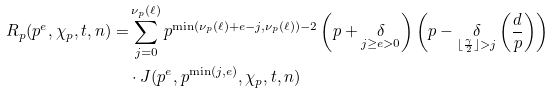Convert formula to latex. <formula><loc_0><loc_0><loc_500><loc_500>R _ { p } ( p ^ { e } , \chi _ { p } , t , n ) = & \sum _ { j = 0 } ^ { \nu _ { p } ( \ell ) } p ^ { \min ( \nu _ { p } ( \ell ) + e - j , \nu _ { p } ( \ell ) ) - 2 } \left ( p + \underset { j \geq e > 0 } { \delta } \right ) \left ( p - \underset { \lfloor \frac { \gamma } { 2 } \rfloor > j } { \delta } \left ( \frac { d } { p } \right ) \right ) \\ & \cdot J ( p ^ { e } , p ^ { \min ( j , e ) } , \chi _ { p } , t , n )</formula> 